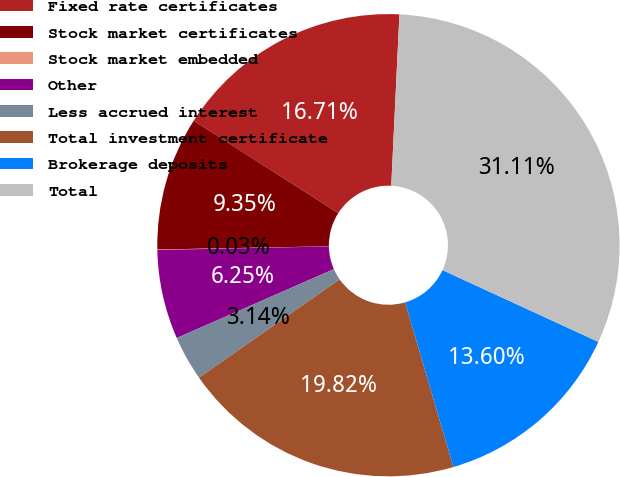Convert chart. <chart><loc_0><loc_0><loc_500><loc_500><pie_chart><fcel>Fixed rate certificates<fcel>Stock market certificates<fcel>Stock market embedded<fcel>Other<fcel>Less accrued interest<fcel>Total investment certificate<fcel>Brokerage deposits<fcel>Total<nl><fcel>16.71%<fcel>9.35%<fcel>0.03%<fcel>6.25%<fcel>3.14%<fcel>19.82%<fcel>13.6%<fcel>31.11%<nl></chart> 